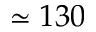Convert formula to latex. <formula><loc_0><loc_0><loc_500><loc_500>\simeq 1 3 0</formula> 